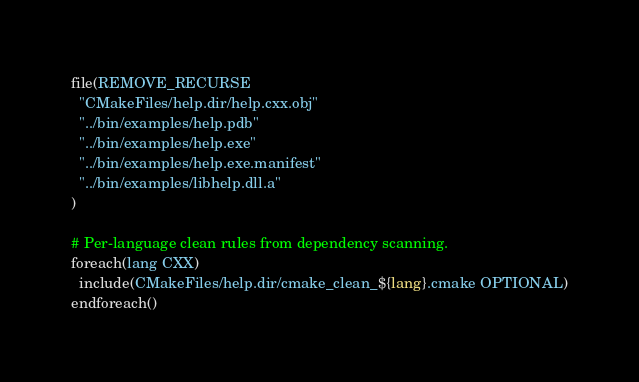<code> <loc_0><loc_0><loc_500><loc_500><_CMake_>file(REMOVE_RECURSE
  "CMakeFiles/help.dir/help.cxx.obj"
  "../bin/examples/help.pdb"
  "../bin/examples/help.exe"
  "../bin/examples/help.exe.manifest"
  "../bin/examples/libhelp.dll.a"
)

# Per-language clean rules from dependency scanning.
foreach(lang CXX)
  include(CMakeFiles/help.dir/cmake_clean_${lang}.cmake OPTIONAL)
endforeach()
</code> 